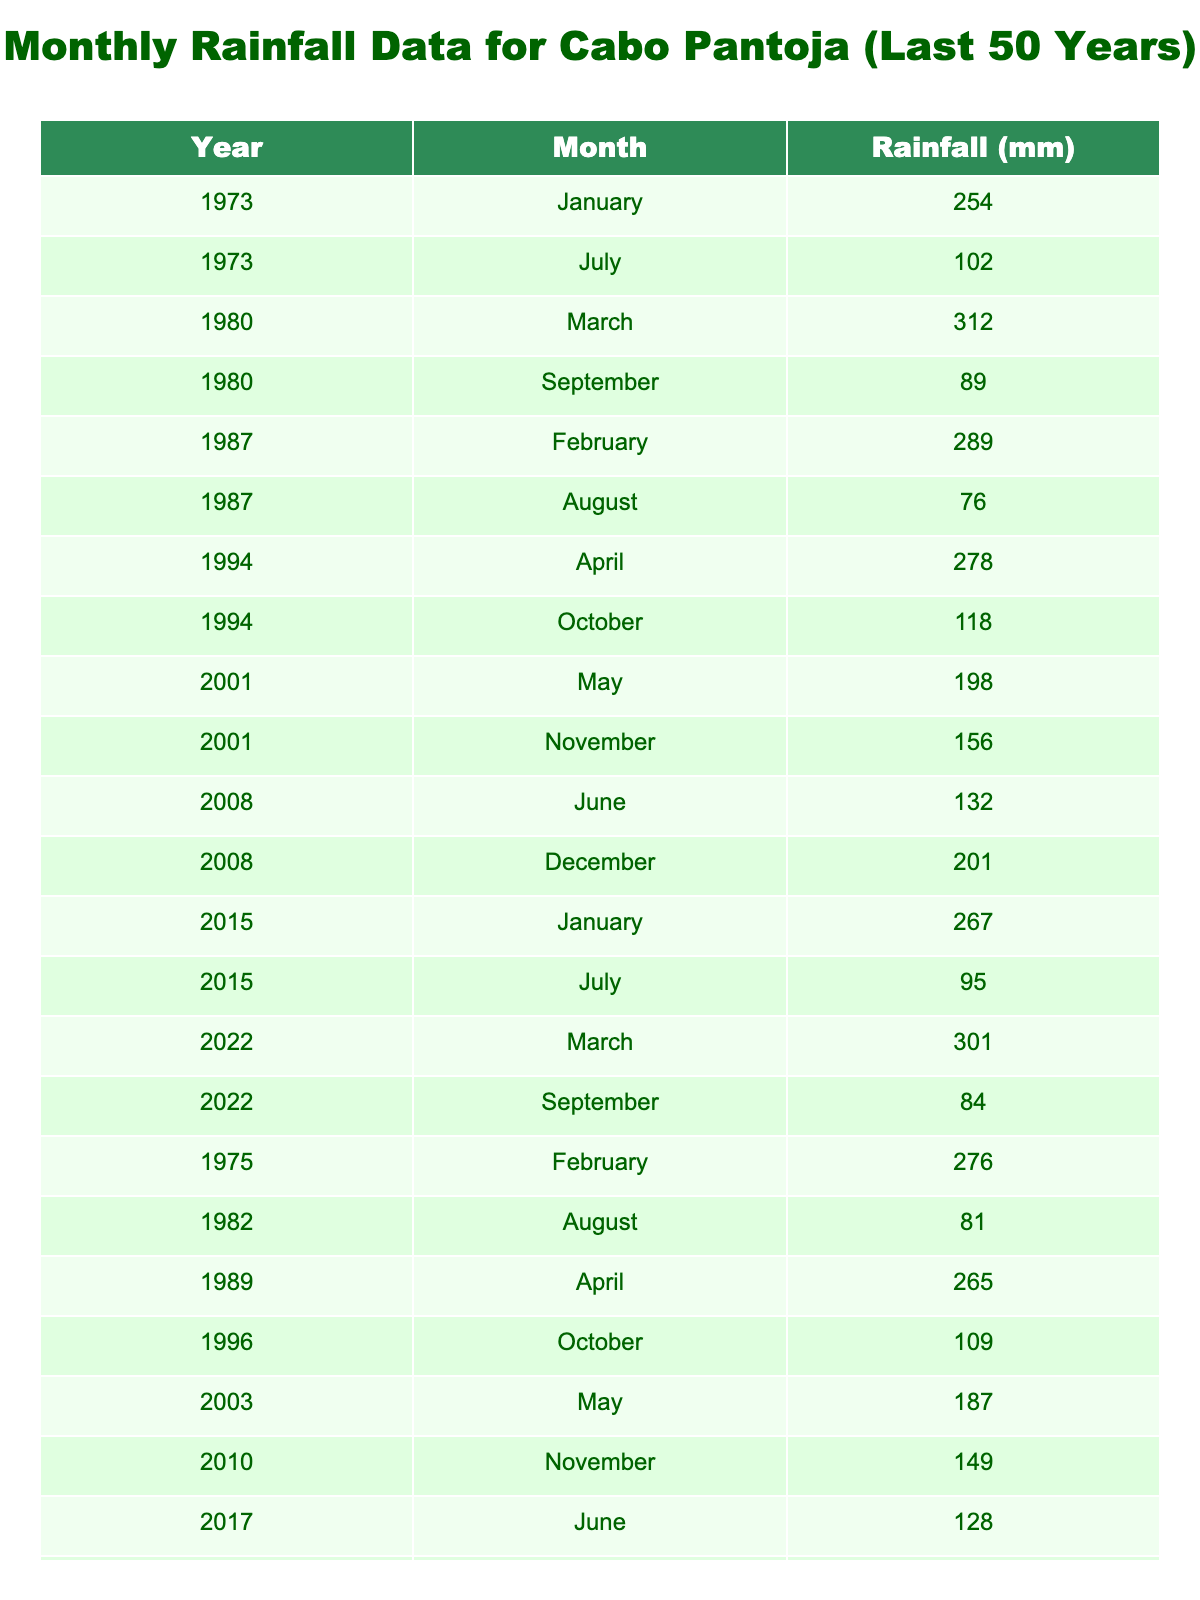What was the highest recorded rainfall in Cabo Pantoja? By scanning the table, the highest rainfall recorded is 312 mm in March 1980.
Answer: 312 mm In which year was the lowest recorded rainfall? Looking through the table, the lowest recorded rainfall is 76 mm in August 1987.
Answer: 76 mm What was the average rainfall in July over the years presented? The total rainfall in July is 102 + 95 + 98 = 295 mm. There are three entries, so the average is 295 / 3 = 98.33 mm.
Answer: 98.33 mm Did Cabo Pantoja experience any rainfall in December for the years presented? Yes, there are two entries for December: 213 mm in 1978 and 201 mm in 2008, confirming that rainfall occurred in December.
Answer: Yes Which month had the highest recorded rainfall in 2022? In 2022, March had the highest recorded rainfall at 301 mm, while September had 84 mm.
Answer: March What was the total rainfall recorded over the 50 years? By summing all rainfall data from the table, the total rainfall amount equals to 254 + 102 + 312 + 89 + 289 + 76 + 278 + 118 + 198 + 156 + 132 + 201 + 267 + 95 + 301 + 84 + 276 + 81 + 265 + 109 + 187 + 149 + 128 + 213 + 248 + 98 + 305 + 87 + 283 + 79 = 4919 mm.
Answer: 4919 mm What is the rainfall difference between the wettest month and the driest month on the table? The wettest month is March 1980 with 312 mm, and the driest month is August 1987 with 76 mm. Thus, the difference is 312 - 76 = 236 mm.
Answer: 236 mm How many years had recorded rainfall in February? By reviewing the data, February had recorded rainfall in the years 1975, 1987, and 2013, making a total of three years.
Answer: 3 years Was the rainfall in June for any year less than 150 mm? Yes, June 2008 had 132 mm, which is less than 150 mm.
Answer: Yes What pattern do you observe for July rainfall over the years? July experiences varying amounts of rainfall, ranging from 95 mm to 102 mm, showing a generally low amount compared to other months and no significant upward trend.
Answer: Varying low amounts 